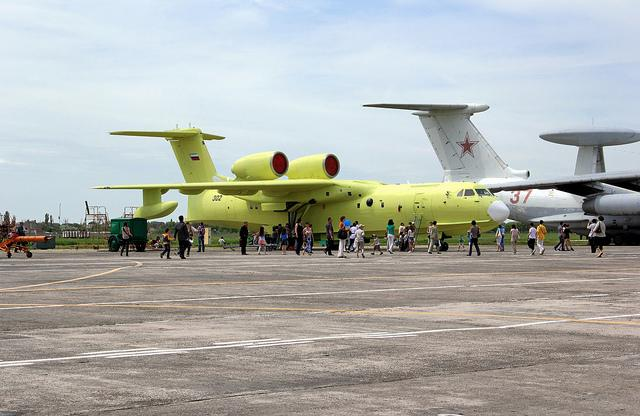What item is painted in an unconventional color? airplane 